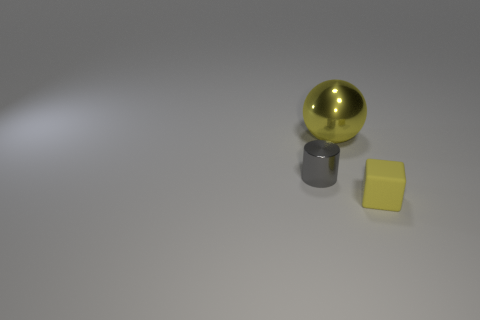Add 2 small rubber things. How many objects exist? 5 Subtract all blocks. How many objects are left? 2 Add 2 large yellow objects. How many large yellow objects are left? 3 Add 3 tiny yellow cubes. How many tiny yellow cubes exist? 4 Subtract 0 cyan blocks. How many objects are left? 3 Subtract all small yellow rubber blocks. Subtract all blocks. How many objects are left? 1 